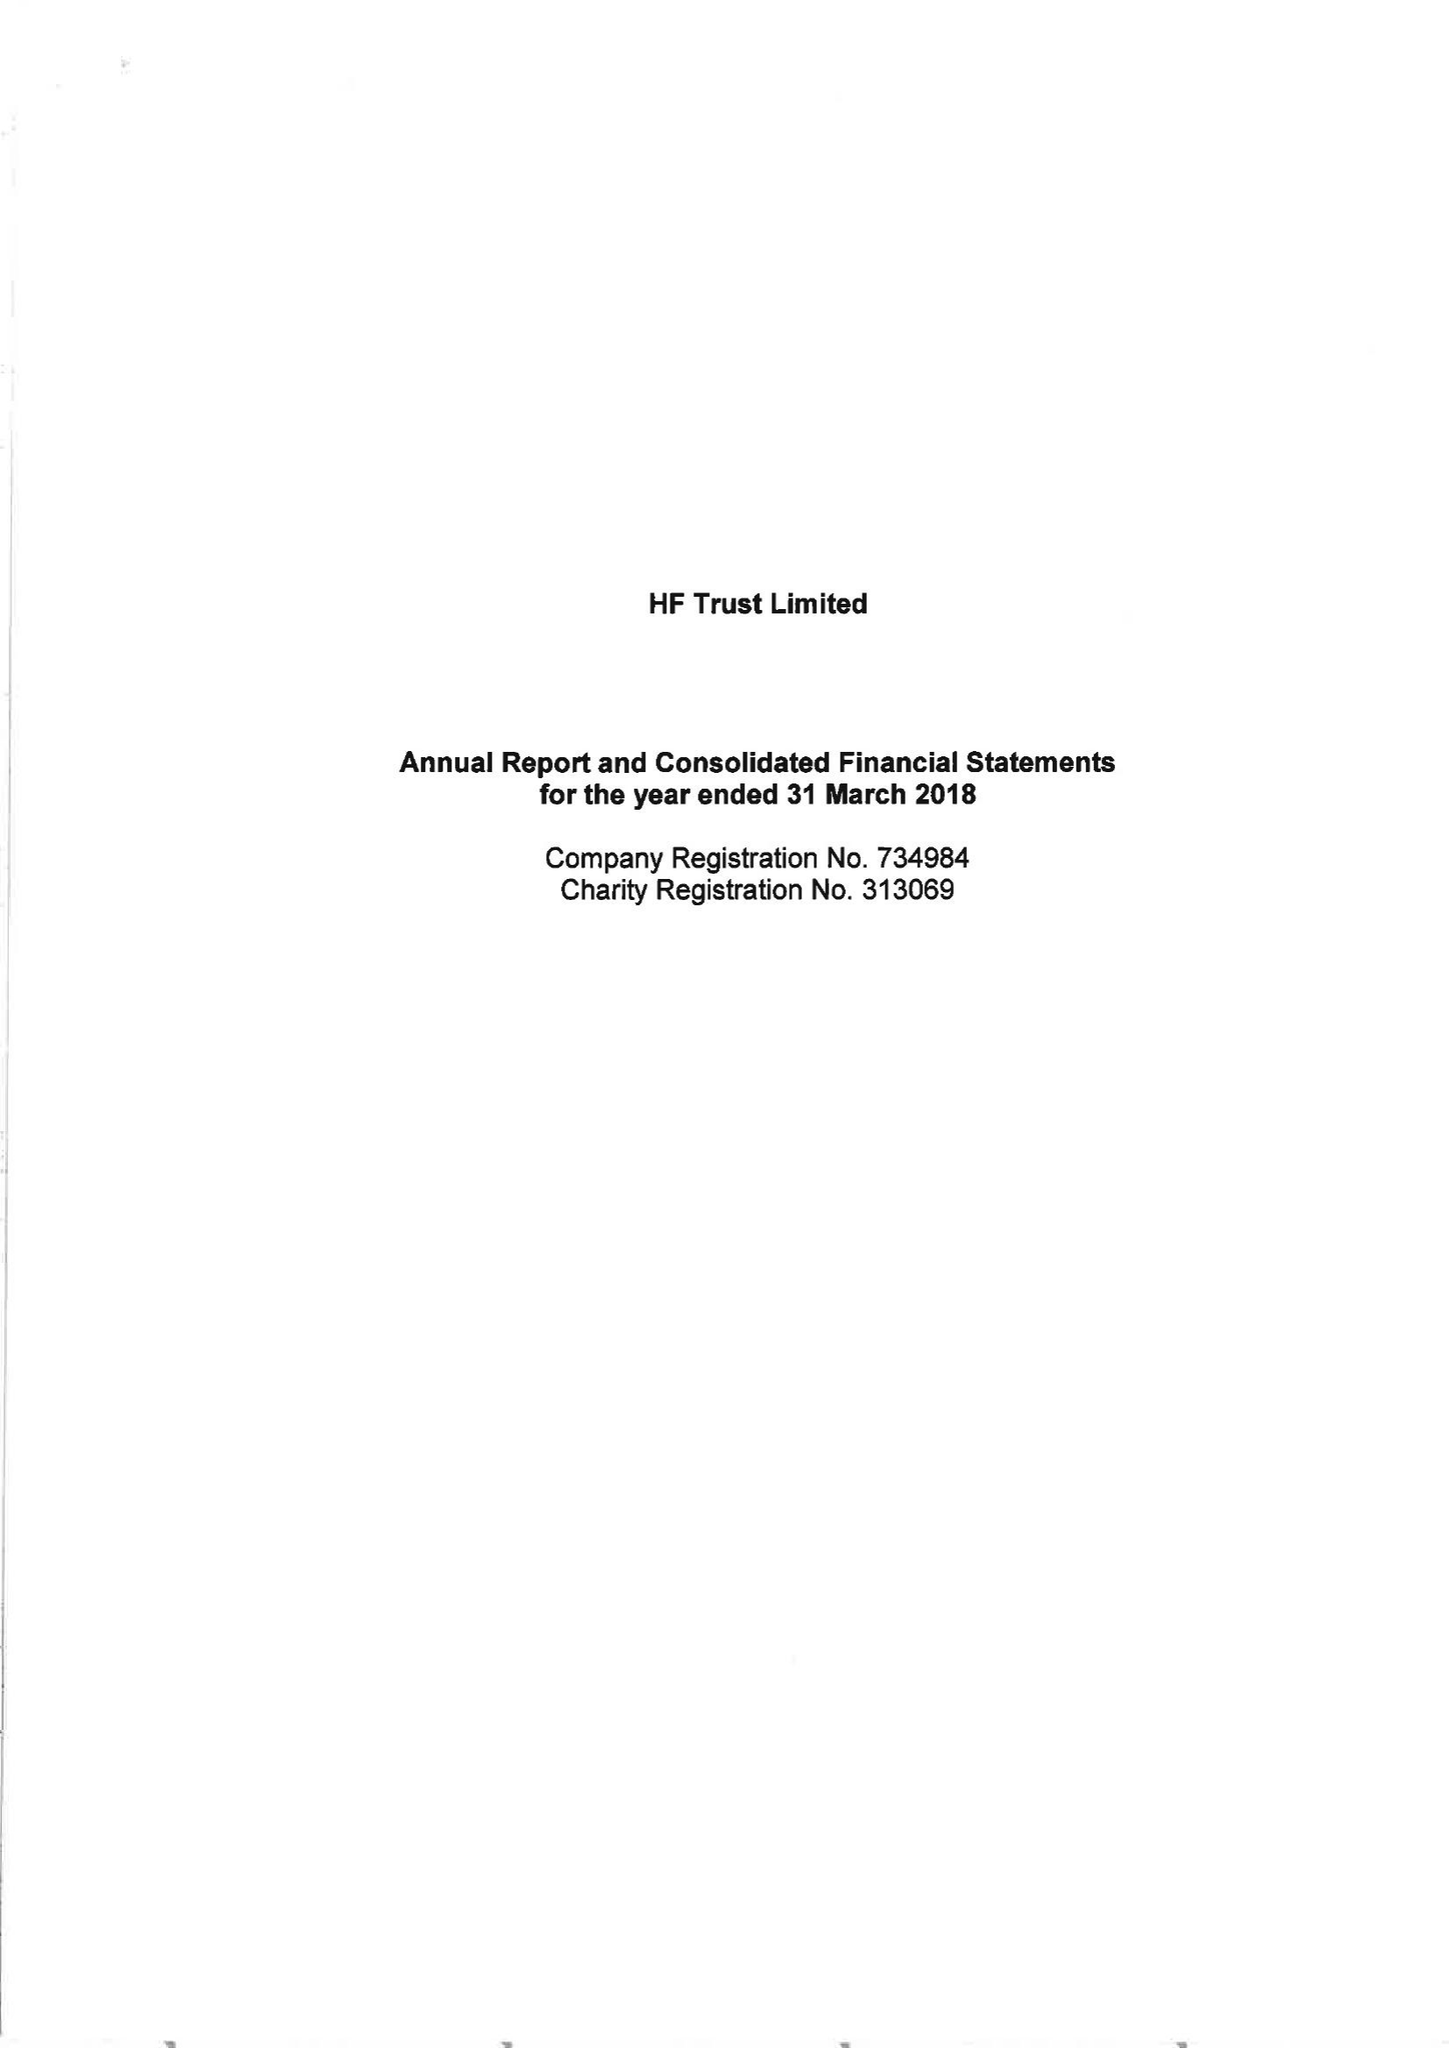What is the value for the spending_annually_in_british_pounds?
Answer the question using a single word or phrase. 78707000.00 